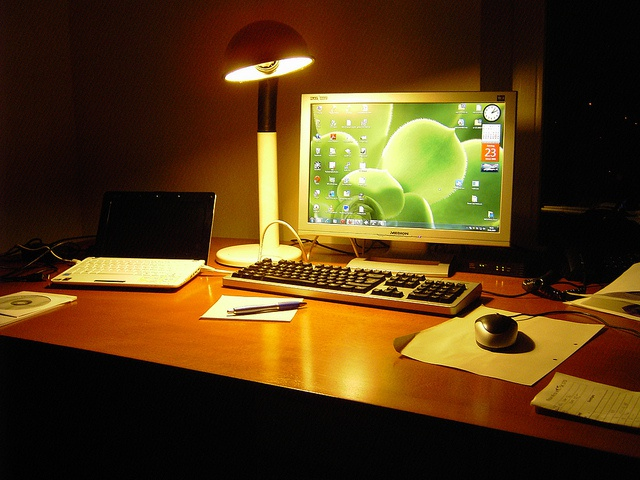Describe the objects in this image and their specific colors. I can see tv in black, khaki, beige, and olive tones, laptop in black, khaki, and lightyellow tones, keyboard in black, olive, maroon, and orange tones, keyboard in black, khaki, lightyellow, and gold tones, and mouse in black, maroon, orange, and olive tones in this image. 